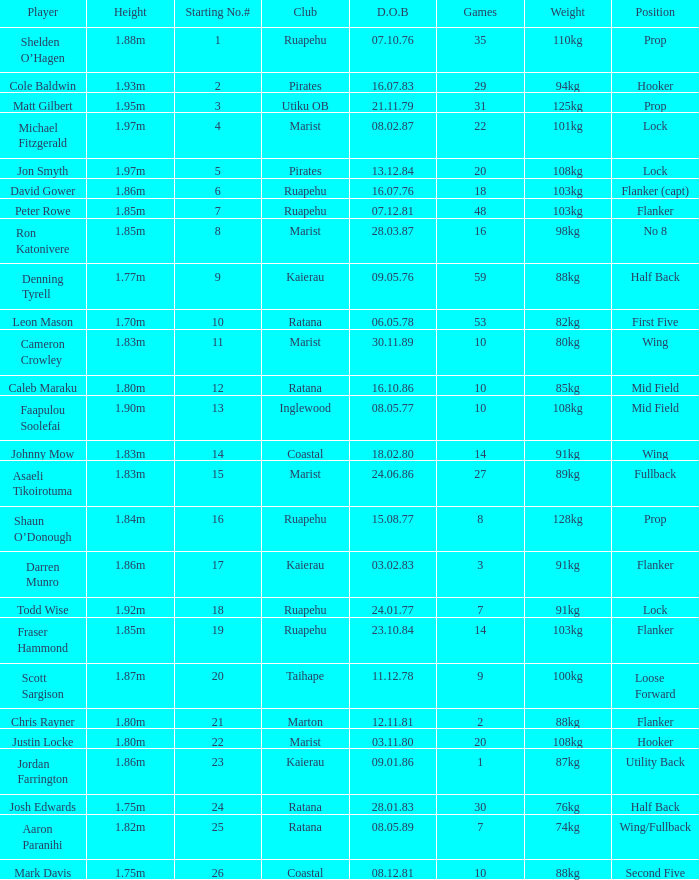What position does the player Todd Wise play in? Lock. 